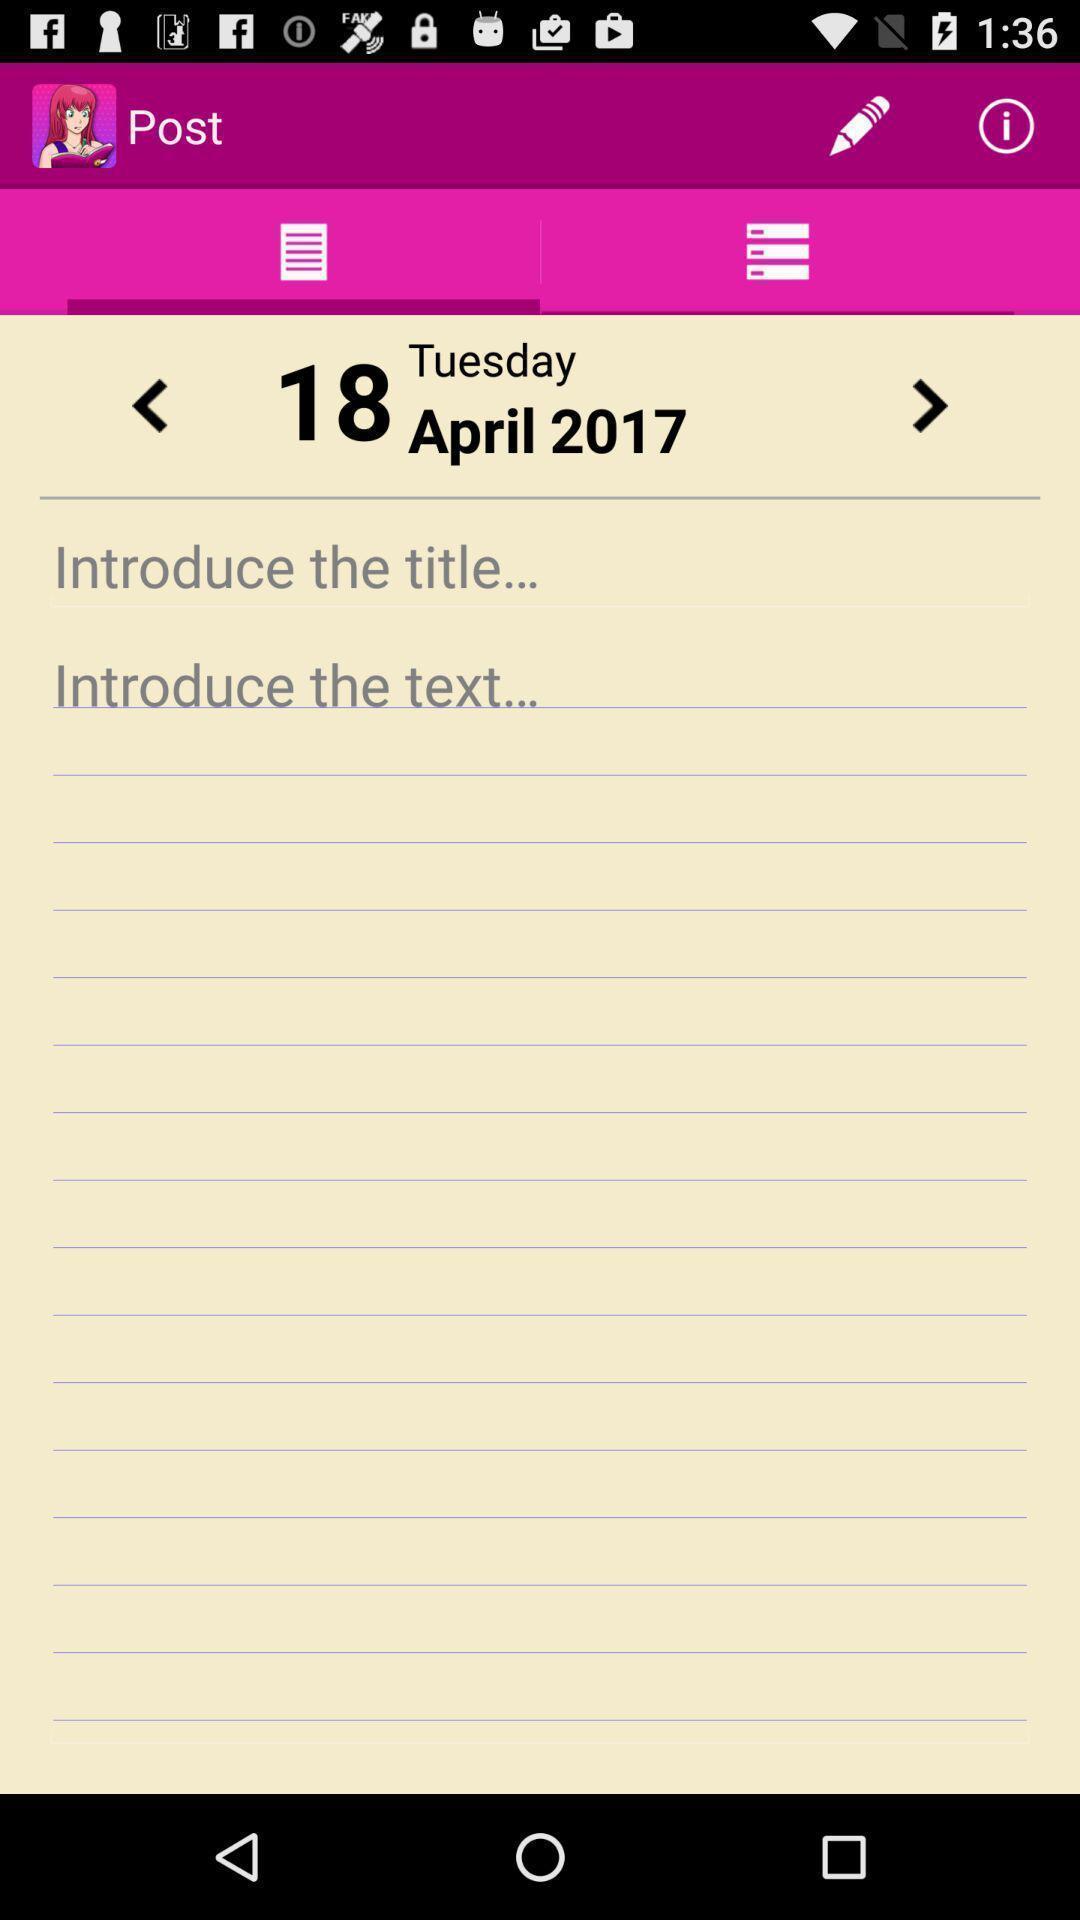Explain the elements present in this screenshot. Page for adding notes. 